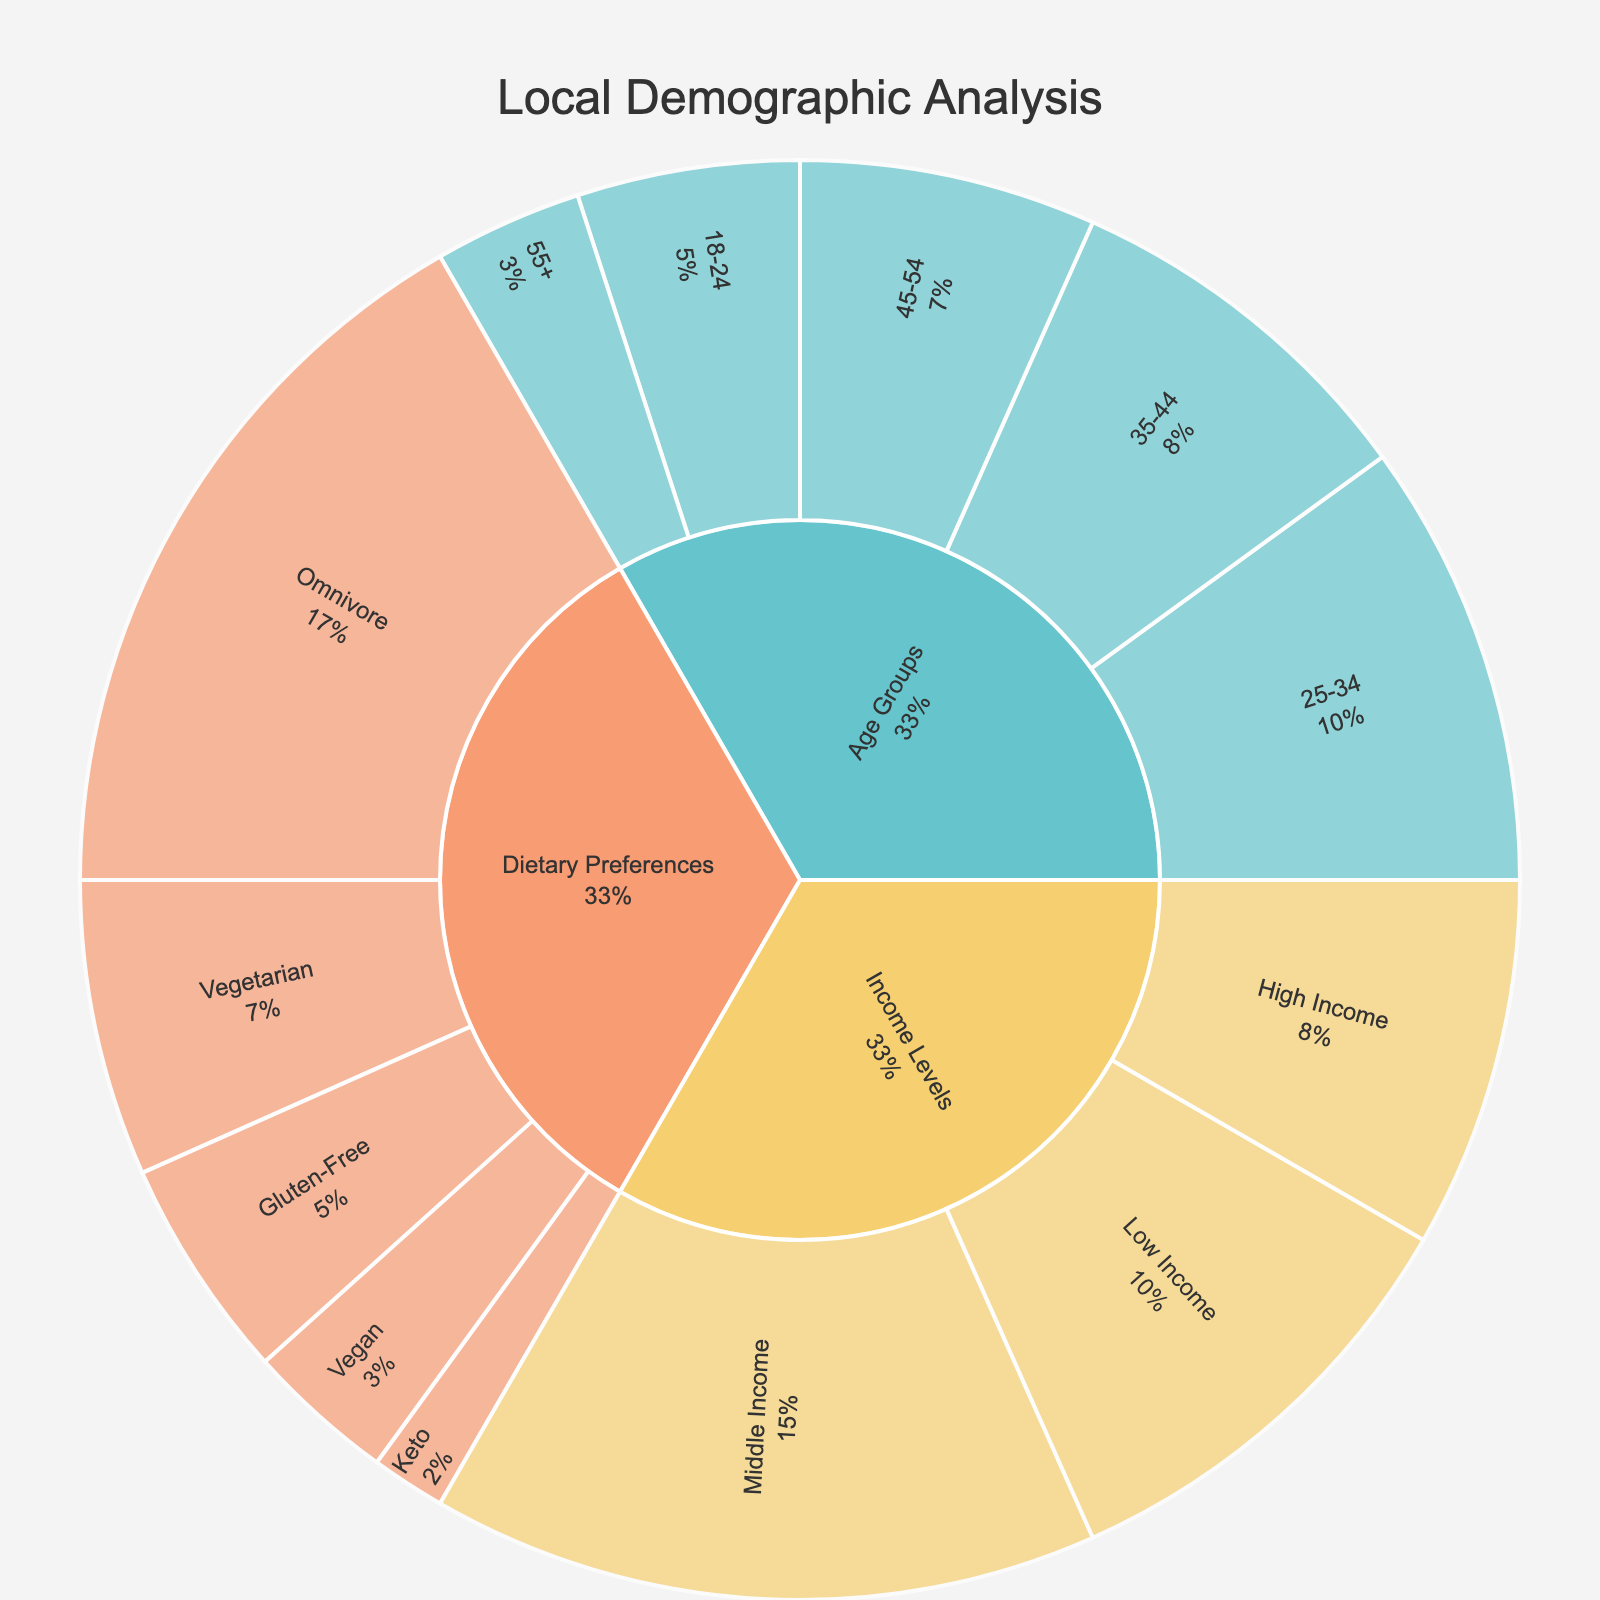What is the title of the Sunburst Plot? The title appears at the top center of the plot and reads "Local Demographic Analysis."
Answer: Local Demographic Analysis What is the largest age group in the dataset? By examining the plot, the 25-34 age group has the largest segment among the age groups, colored distinctly and displaying a value of 30.
Answer: 25-34 What is the smallest dietary preference segment shown in the plot? Observing the size of the segments and the values displayed, the Keto dietary preference is the smallest with a value of 5.
Answer: Keto Which income level has the highest value? Among the income levels, the Middle Income segment is visually the largest and shows a value of 45.
Answer: Middle Income What is the total value of the age groups? Summing the values of all age group segments: 15 (18-24) + 30 (25-34) + 25 (35-44) + 20 (45-54) + 10 (55+) = 100.
Answer: 100 How does the value of the Low Income level compare to the High Income level? In the plot, Low Income has a value of 30, and High Income has a value of 25. Comparing these, Low Income is higher by 5.
Answer: Low Income is higher by 5 What percentage of the total does the Vegetarian dietary preference represent? The total value of all dietary preferences is 50 (Omnivore) + 20 (Vegetarian) + 10 (Vegan) + 15 (Gluten-Free) + 5 (Keto) = 100. The Vegetarian value is 20, which is 20% of the total.
Answer: 20% If you combine the values of the Omnivore and Gluten-Free dietary preferences, what is their combined percentage of the total dietary preferences? Combine Omnivore (50) and Gluten-Free (15): 50 + 15 = 65. The total is 100, so the combined percentage is (65/100) * 100 = 65%.
Answer: 65% How does the size of the 35-44 age group's segment compare to the 45-54 age group's segment? The 35-44 age group has a value of 25, while the 45-54 age group has a value of 20. Comparing these, the 35-44 age group is larger by 5.
Answer: 35-44 is larger by 5 What is the average value of all income levels? The sum of the income levels is 30 (Low Income) + 45 (Middle Income) + 25 (High Income) = 100. There are 3 segments, so the average is 100/3 ≈ 33.33.
Answer: ≈ 33.33 